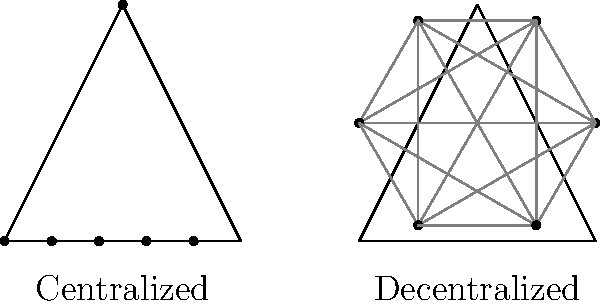In the context of peer-to-peer networking in gaming, which model typically offers better scalability and fault tolerance, and why? To answer this question, let's compare the centralized and decentralized (peer-to-peer) models:

1. Centralized Model:
   - All clients connect to a central server
   - Server manages all game state and communication
   - Pros: Easier to manage and secure
   - Cons: Single point of failure, limited scalability

2. Decentralized (Peer-to-Peer) Model:
   - Clients connect directly to each other
   - Game state is distributed among peers
   - Pros: No single point of failure, better scalability
   - Cons: More complex to implement and secure

3. Scalability:
   - Centralized: Limited by server capacity
   - Decentralized: Can scale more easily as new peers join

4. Fault Tolerance:
   - Centralized: If the server fails, the entire network fails
   - Decentralized: If one peer fails, the network can continue functioning

5. Network Traffic:
   - Centralized: All traffic goes through the server, potentially causing bottlenecks
   - Decentralized: Traffic is distributed among peers, reducing bottlenecks

Given these factors, the decentralized (peer-to-peer) model typically offers better scalability and fault tolerance. It can handle more players without a single point of failure, and the network remains operational even if some peers disconnect.
Answer: Decentralized (peer-to-peer) model 